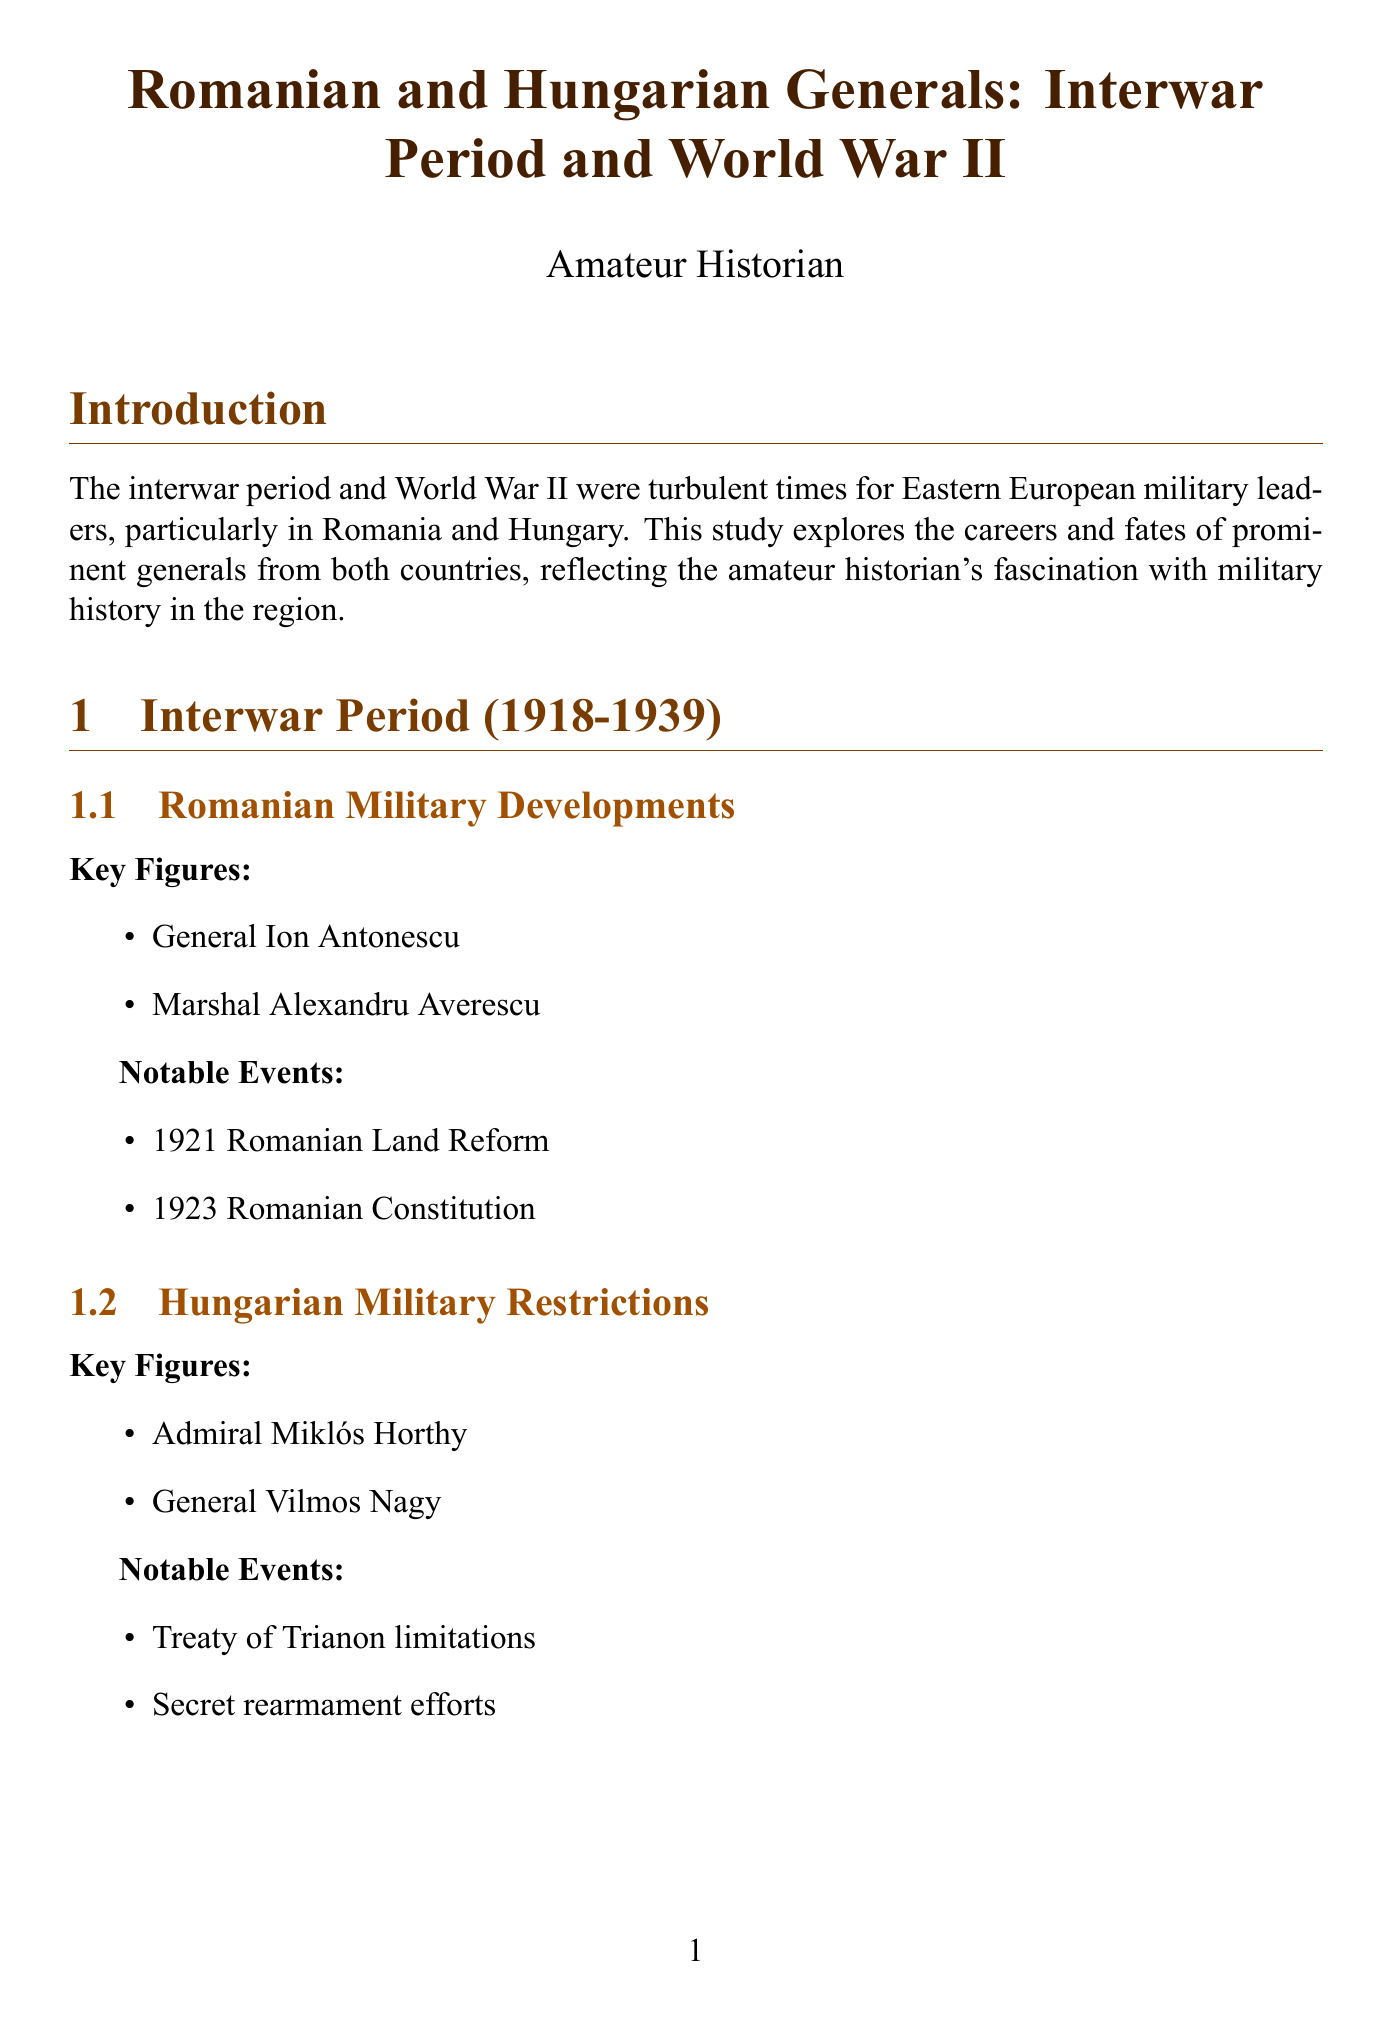What years does the interwar period cover? The interwar period is defined in the document as spanning from 1918 to 1939.
Answer: 1918-1939 Who was the Conducător of Romania during World War II? The document states that Ion Antonescu was the Conducător of Romania during World War II.
Answer: Ion Antonescu What notable event occurred in 1921 related to Romania? The document lists the 1921 Romanian Land Reform as a notable event during the interwar period.
Answer: 1921 Romanian Land Reform Which battle illustrates the encirclement of Axis forces? The document specifies that the Battle of Stalingrad Diagram illustrates the encirclement of Axis forces.
Answer: Battle of Stalingrad What aspect of military doctrine is compared between Romania and Hungary? The document notes that both countries adapted German tactics, but Romania maintained a larger and more independent force.
Answer: Military Doctrine What was Admiral Miklós Horthy's role? The document classifies Admiral Miklós Horthy as a key figure for Hungary during the interwar period.
Answer: Admiral of Hungary What happened to Gusztáv Jány after the war? The document indicates that Gusztáv Jány was executed in Hungary in 1947.
Answer: Executed in Hungary in 1947 How many generals from Hungary are mentioned? The document lists two notable Hungarian generals, which gives the count of Hungarian generals mentioned.
Answer: Two 